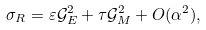<formula> <loc_0><loc_0><loc_500><loc_500>\sigma _ { R } = \varepsilon \mathcal { G } _ { E } ^ { 2 } + \tau \mathcal { G } _ { M } ^ { 2 } + O ( \alpha ^ { 2 } ) ,</formula> 